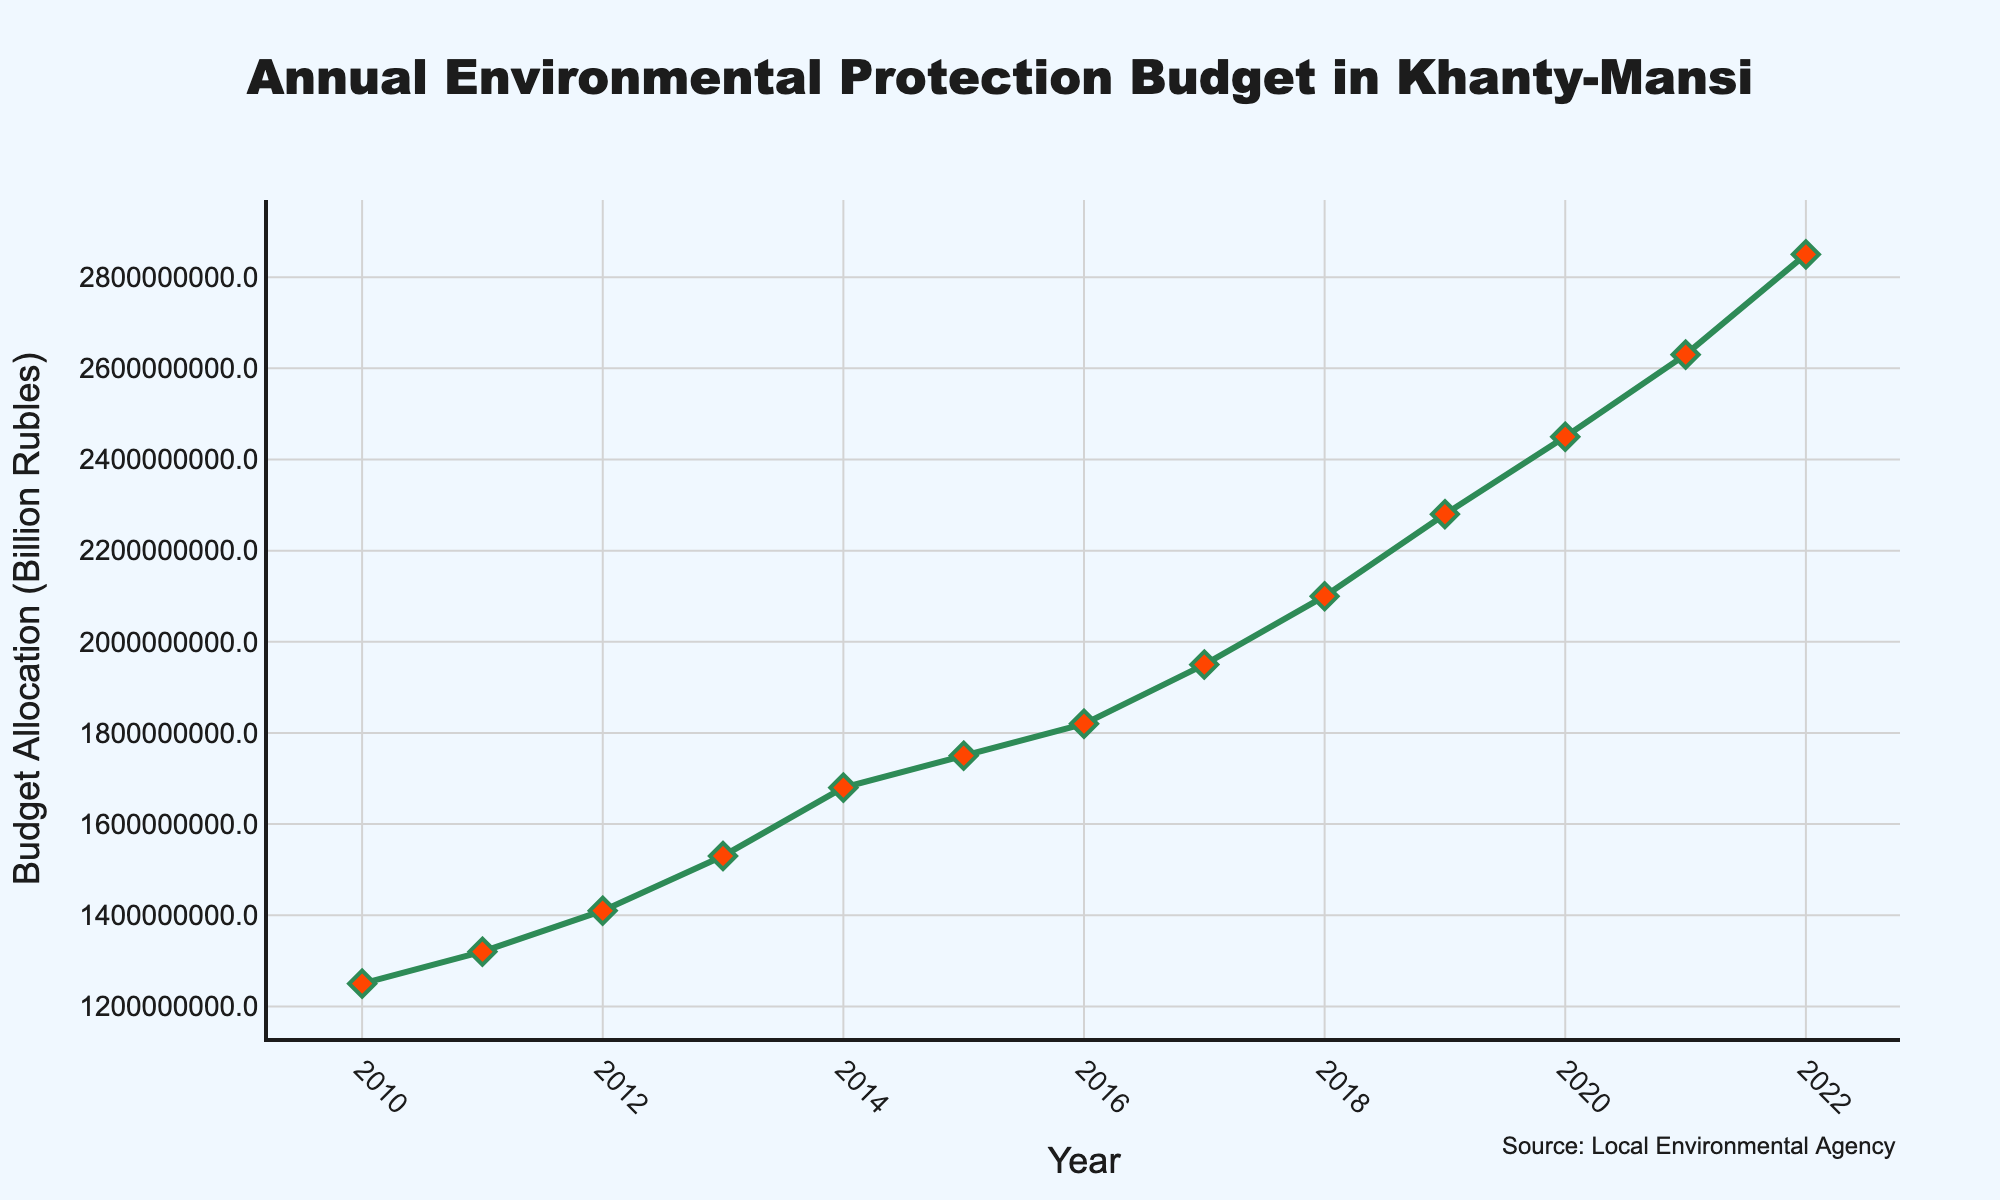What is the budget allocation for environmental protection in the year 2015? Look at the data point corresponding to the year 2015 on the x-axis, and note the value on the y-axis.
Answer: 1750000000 How much did the budget allocation change from 2010 to 2020? Subtract the budget value in 2010 from the budget value in 2020. 2450000000 - 1250000000 = 1200000000
Answer: 1200000000 Which year saw the highest budget allocation? Identify the highest data point on the y-axis and determine the corresponding year on the x-axis.
Answer: 2022 What is the average annual budget allocation for the years between 2010 and 2015 inclusive? Sum the budget values from 2010 to 2015 and divide by the number of years. (1250000000 + 1320000000 + 1410000000 + 1530000000 + 1680000000 + 1750000000) / 6 = 1490000000
Answer: 1490000000 How does the budget allocation in 2013 compare to that in 2017? Compare the values of the budget allocations for the years 2013 and 2017. 1530000000 (2013) vs. 1950000000 (2017) - Since 1950000000 is greater than 1530000000, the allocation in 2017 is higher.
Answer: 2017 is higher By how much did the budget increase from 2017 to 2018? Subtract the budget value in 2017 from the budget value in 2018. 2100000000 - 1950000000 = 150000000
Answer: 150000000 What is the total budget allocation for the years 2010 and 2022? Add the budget values for 2010 and 2022. 1250000000 + 2850000000 = 4100000000
Answer: 4100000000 Which two consecutive years had the smallest increase in budget allocation? Calculate the difference between budgets for each pair of consecutive years and identify the smallest difference. The differences are:
2011-2010: 1320000000 - 1250000000 = 70000000
2012-2011: 1410000000 - 1320000000 = 90000000
2013-2012: 1530000000 - 1410000000 = 120000000
2014-2013: 1680000000 - 1530000000 = 150000000
2015-2014: 1750000000 - 1680000000 = 70000000
2016-2015: 1820000000 - 1750000000 = 70000000
2017-2016: 1950000000 - 1820000000 = 130000000
2018-2017: 2100000000 - 1950000000 = 150000000
2019-2018: 2280000000 - 2100000000 = 180000000
2020-2019: 2450000000 - 2280000000 = 170000000
2021-2020: 2630000000 - 2450000000 = 180000000
2022-2021: 2850000000 - 2630000000 = 220000000
The smallest increase is between 2010 and 2011 and between 2014 and 2015 and between 2015 and 2016, which are all 70000000.
Answer: 2010-2011, 2014-2015 and 2015-2016 What is the median budget allocation for the given years? Order the budget values and find the middle value. For 13 values, the median is the 7th value in ordered list:
1250000000, 1320000000, 1410000000, 1530000000, 1680000000, 1750000000, 1820000000, 1950000000, 2100000000, 2280000000, 2450000000, 2630000000, 2850000000. The 7th value is 1820000000.
Answer: 1820000000 